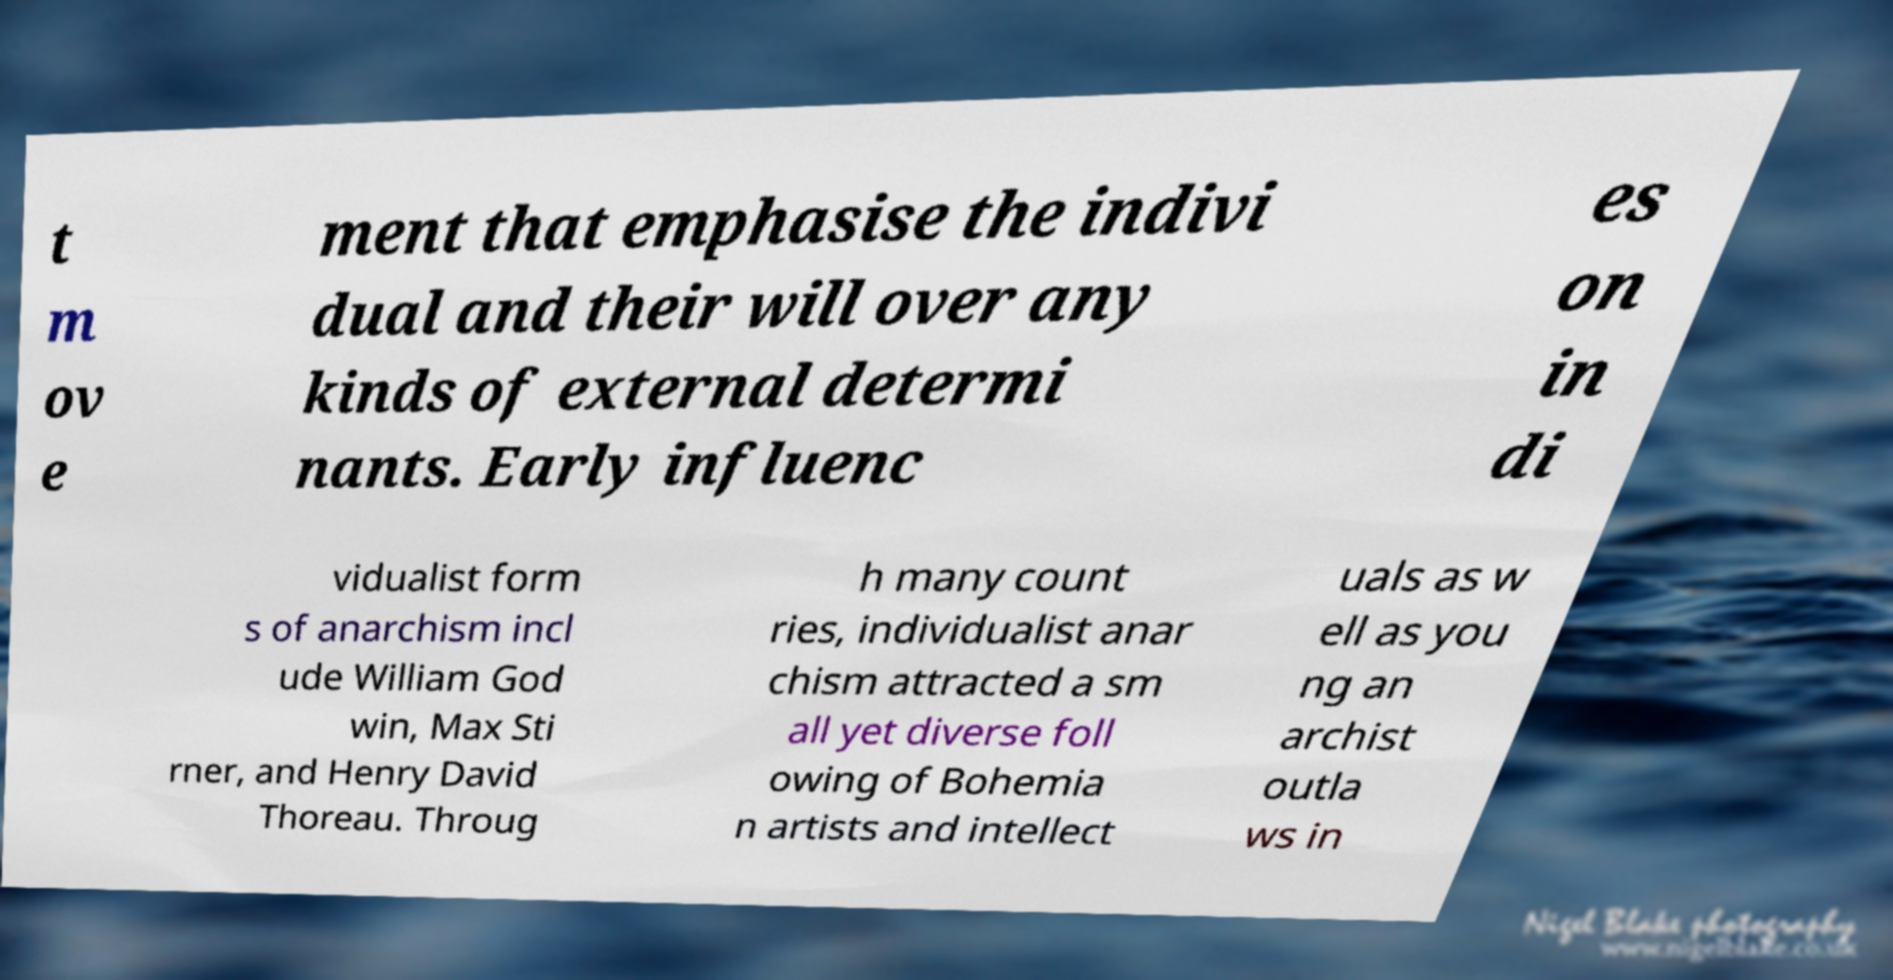For documentation purposes, I need the text within this image transcribed. Could you provide that? t m ov e ment that emphasise the indivi dual and their will over any kinds of external determi nants. Early influenc es on in di vidualist form s of anarchism incl ude William God win, Max Sti rner, and Henry David Thoreau. Throug h many count ries, individualist anar chism attracted a sm all yet diverse foll owing of Bohemia n artists and intellect uals as w ell as you ng an archist outla ws in 